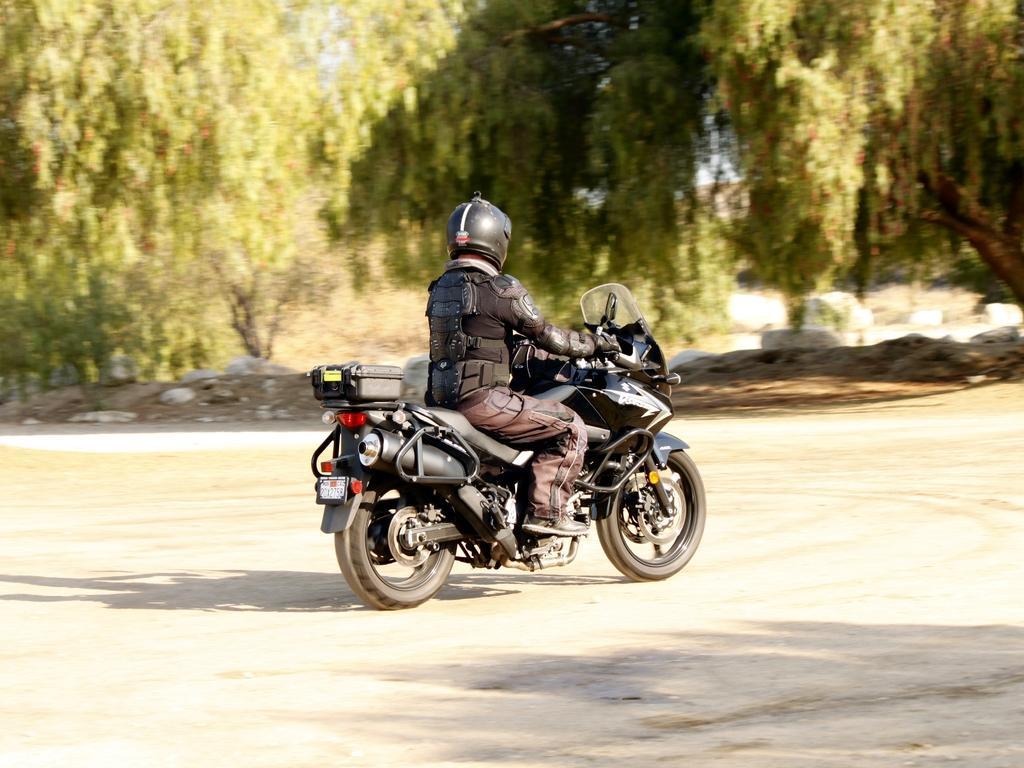Describe this image in one or two sentences. In this picture there is a man in the center of the image, on a bike and there are trees at the top side of the image. 